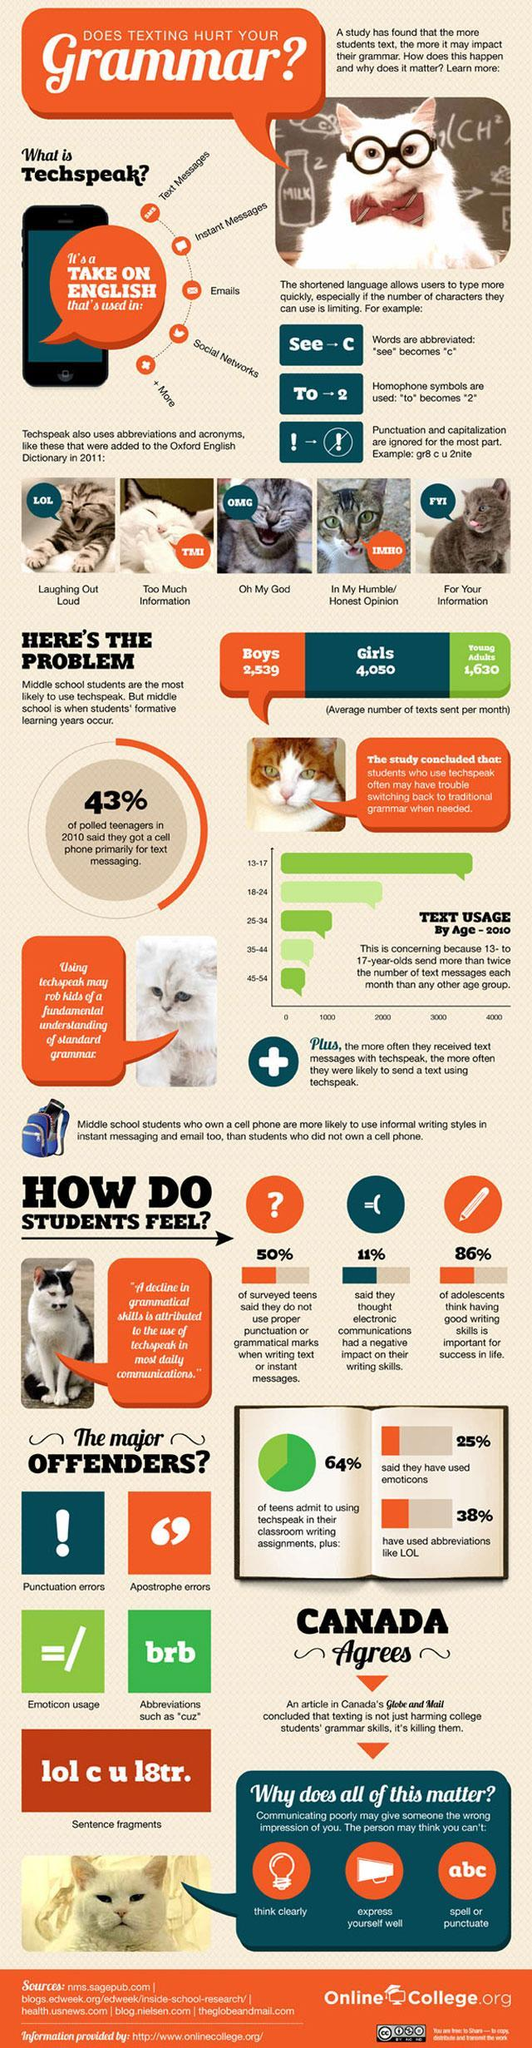Which newpaper is mentioned?
Answer the question with a short phrase. Globe and Mail Which age group is the second biggest in text usage? 18-24 